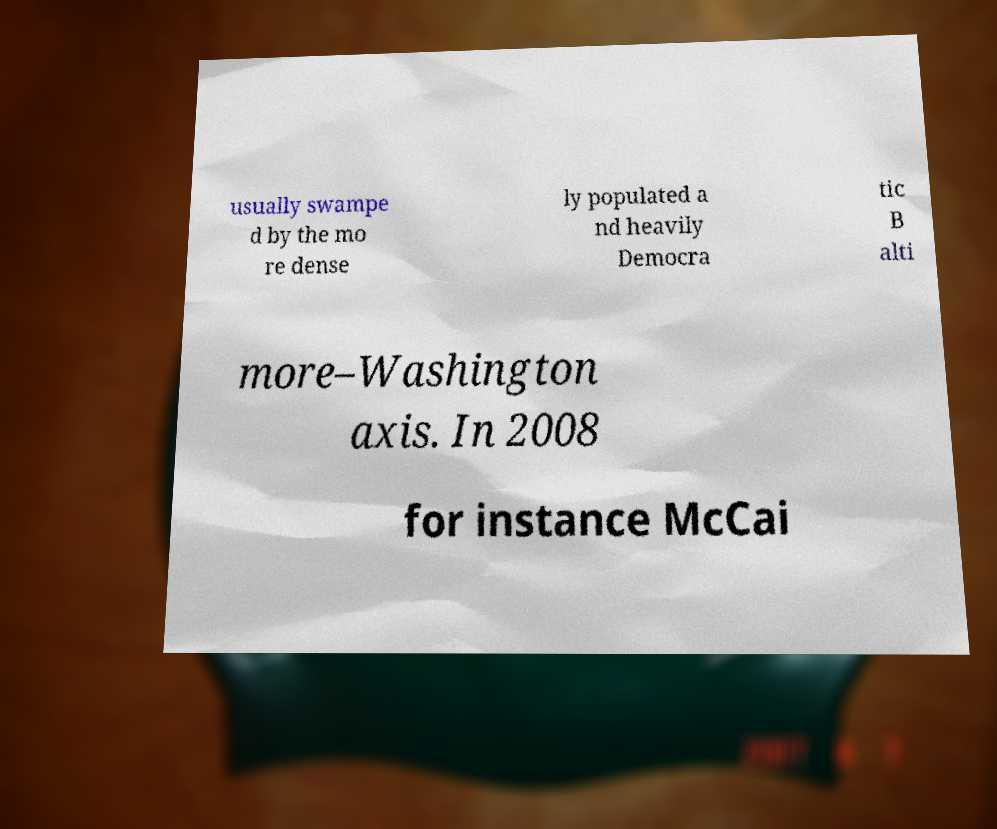For documentation purposes, I need the text within this image transcribed. Could you provide that? usually swampe d by the mo re dense ly populated a nd heavily Democra tic B alti more–Washington axis. In 2008 for instance McCai 